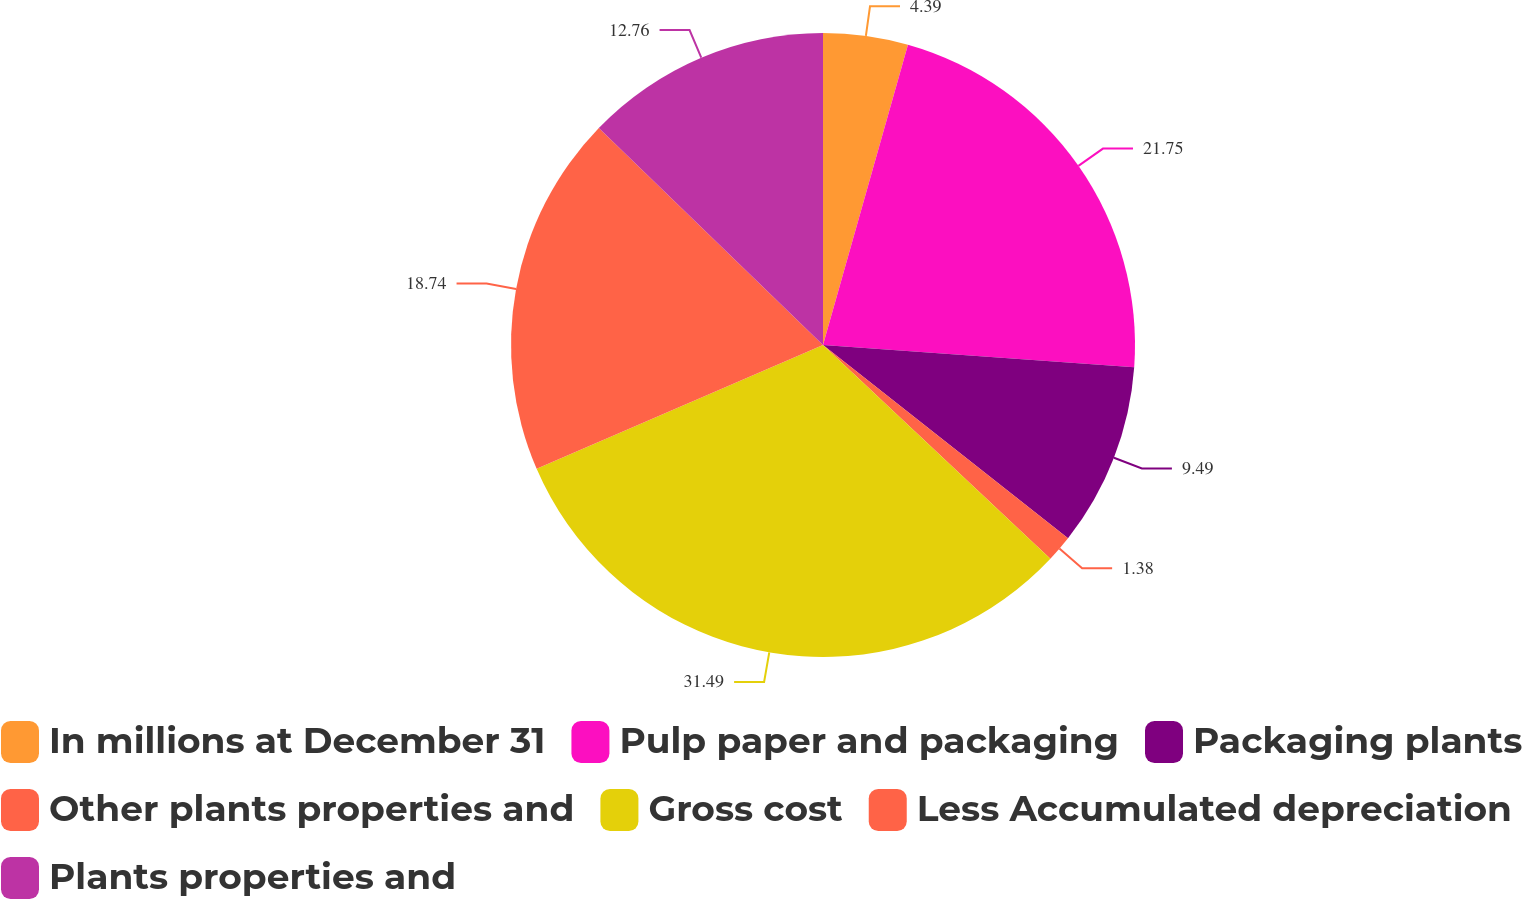<chart> <loc_0><loc_0><loc_500><loc_500><pie_chart><fcel>In millions at December 31<fcel>Pulp paper and packaging<fcel>Packaging plants<fcel>Other plants properties and<fcel>Gross cost<fcel>Less Accumulated depreciation<fcel>Plants properties and<nl><fcel>4.39%<fcel>21.75%<fcel>9.49%<fcel>1.38%<fcel>31.5%<fcel>18.74%<fcel>12.76%<nl></chart> 